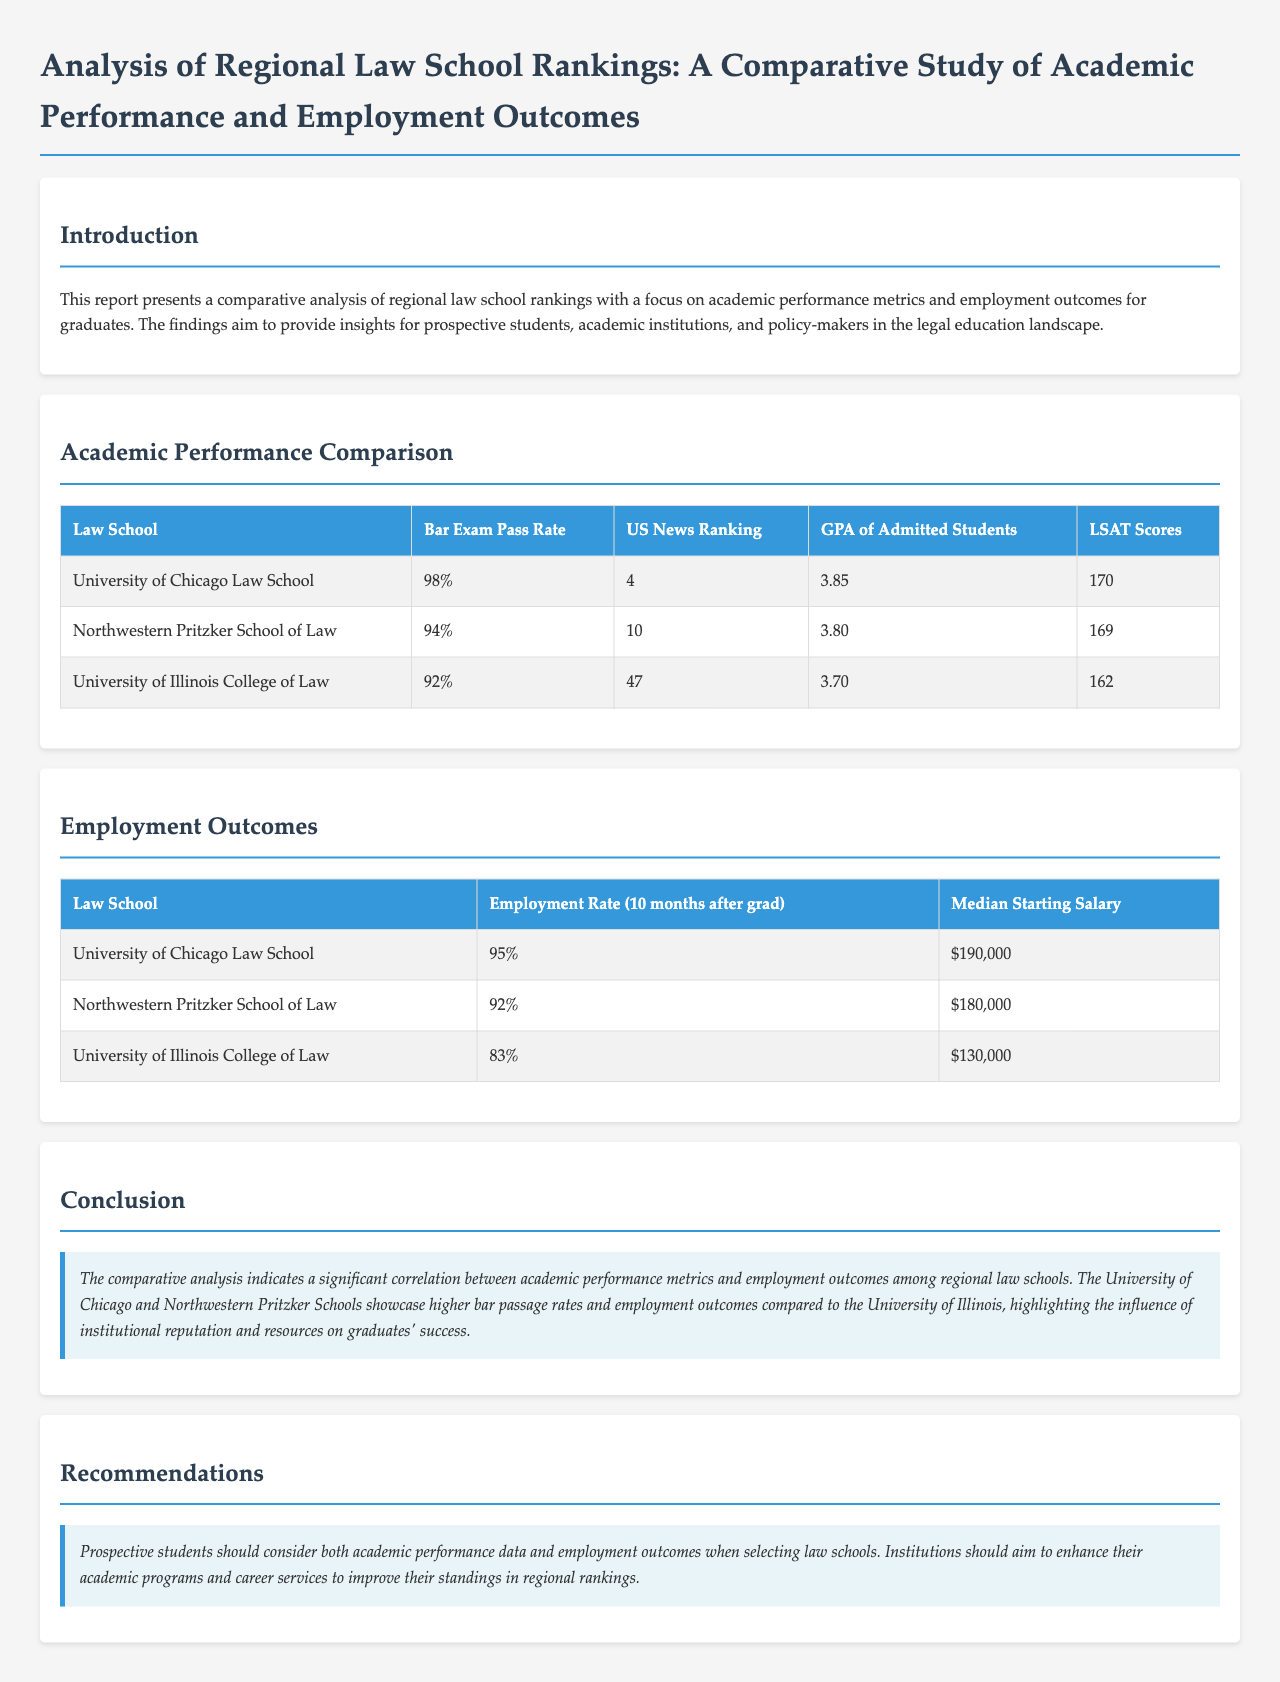What is the bar exam pass rate for the University of Chicago Law School? The bar exam pass rate for the University of Chicago Law School is presented in the academic performance table.
Answer: 98% What is the median starting salary for graduates from Northwestern Pritzker School of Law? The median starting salary is specified in the employment outcomes table for Northwestern Pritzker School of Law.
Answer: $180,000 How many law schools are compared in the academic performance section? The academic performance section provides data for three law schools.
Answer: Three What is the employment rate for the University of Illinois College of Law? The employment rate is shown in the employment outcomes table for the University of Illinois College of Law.
Answer: 83% Which law school has the highest GPA of admitted students? The GPA of admitted students table indicates which law school has the highest GPA.
Answer: University of Chicago Law School What is the US News ranking of the University of Illinois College of Law? The US News ranking is listed in the academic performance table for the University of Illinois College of Law.
Answer: 47 Which law school has the lowest bar exam pass rate? The bar exam pass rates are compared in the academic performance section, revealing which school has the lowest.
Answer: University of Illinois College of Law In the conclusion, what is highlighted as influencing graduates' success? The conclusion points out an aspect that influences graduates' success among regional law schools.
Answer: Institutional reputation and resources 